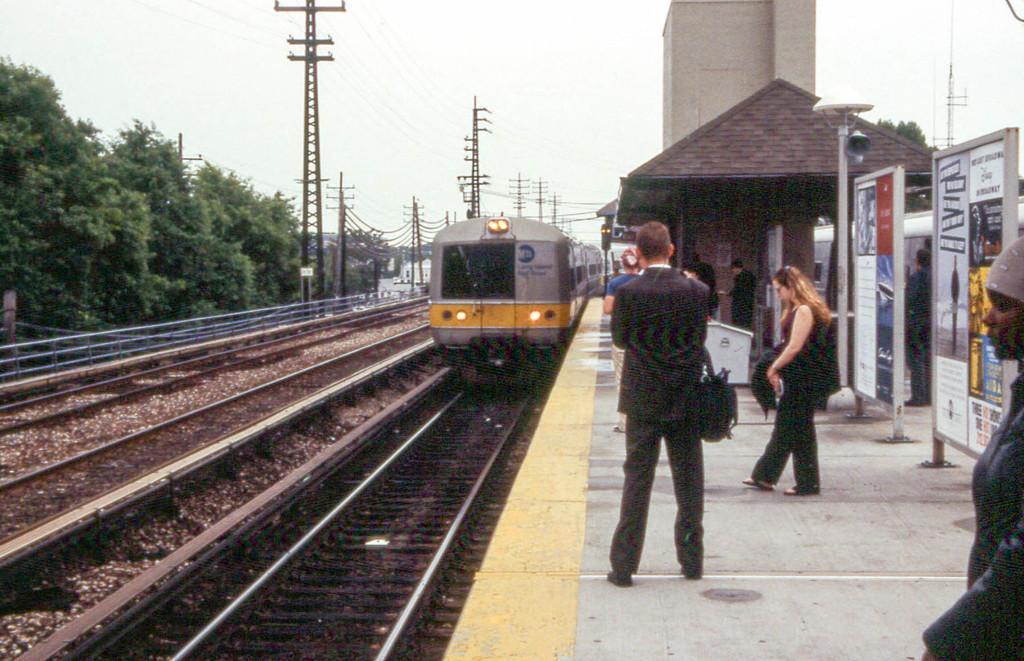Can you describe this image briefly? In this image we can see people standing on the platform, locomotive on the track, empty tracks, electric poles, electric cable, trees, shed, advertisement boards, tower and sky. 